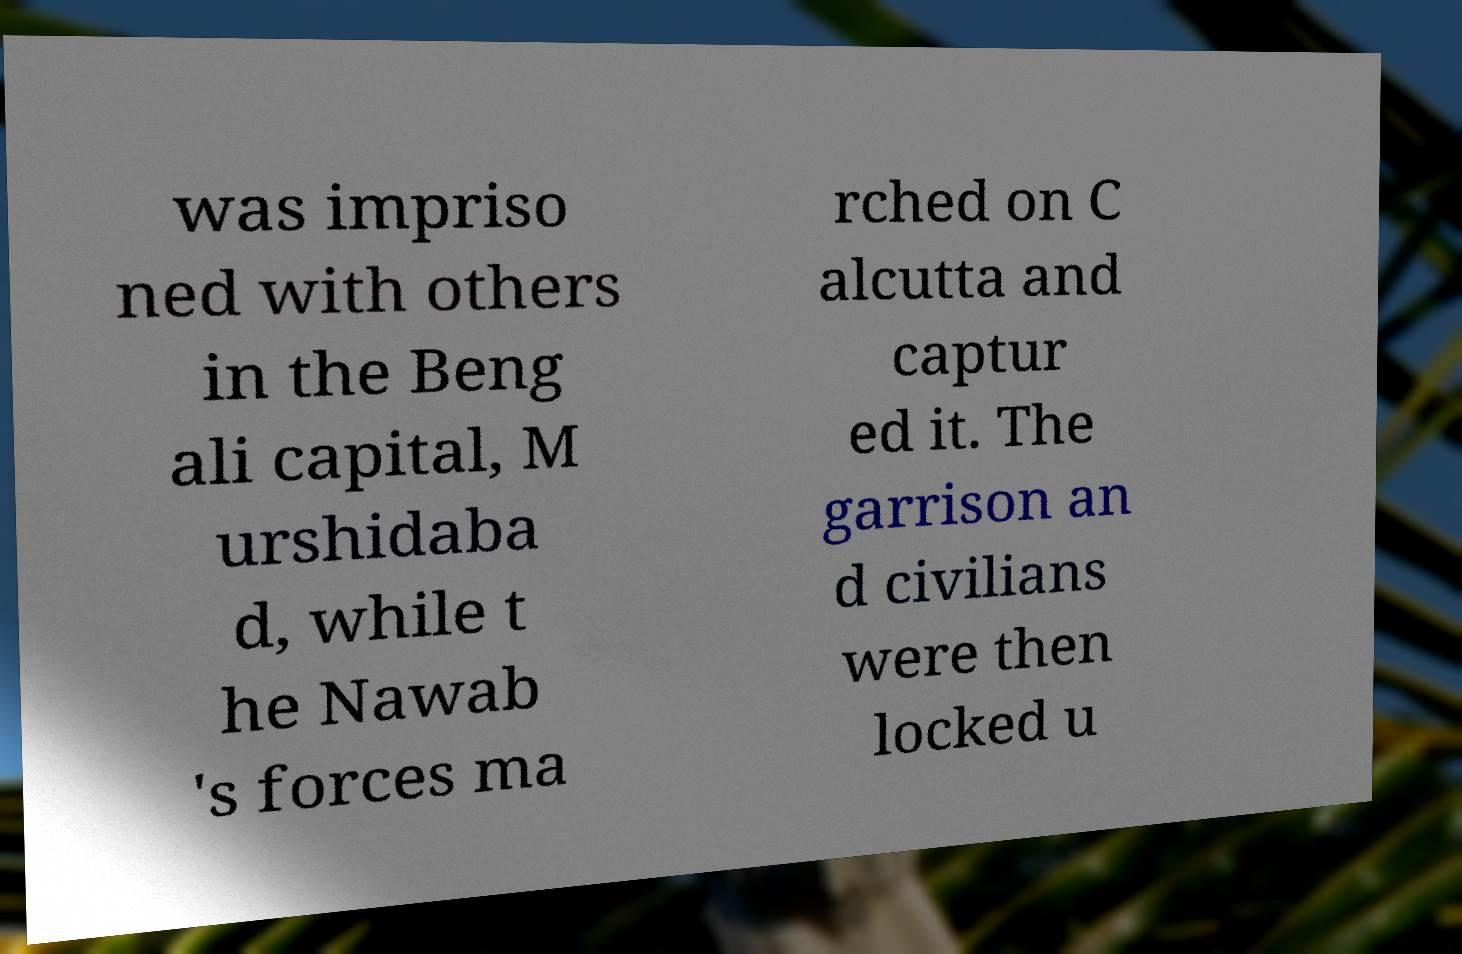Please identify and transcribe the text found in this image. was impriso ned with others in the Beng ali capital, M urshidaba d, while t he Nawab 's forces ma rched on C alcutta and captur ed it. The garrison an d civilians were then locked u 